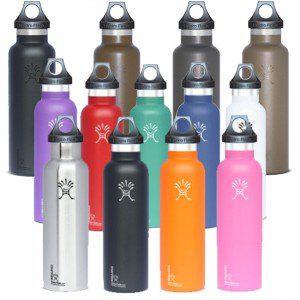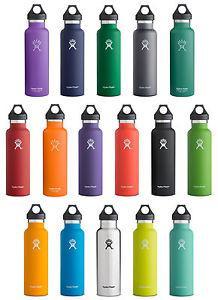The first image is the image on the left, the second image is the image on the right. Considering the images on both sides, is "The left and right image contains the same number of rows of stainless steel water bottles." valid? Answer yes or no. Yes. The first image is the image on the left, the second image is the image on the right. Considering the images on both sides, is "There are fifteen bottles in total." valid? Answer yes or no. No. 